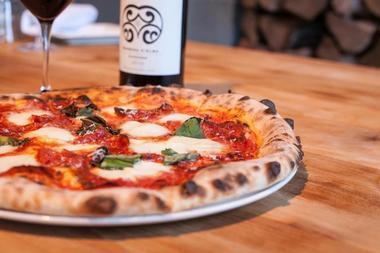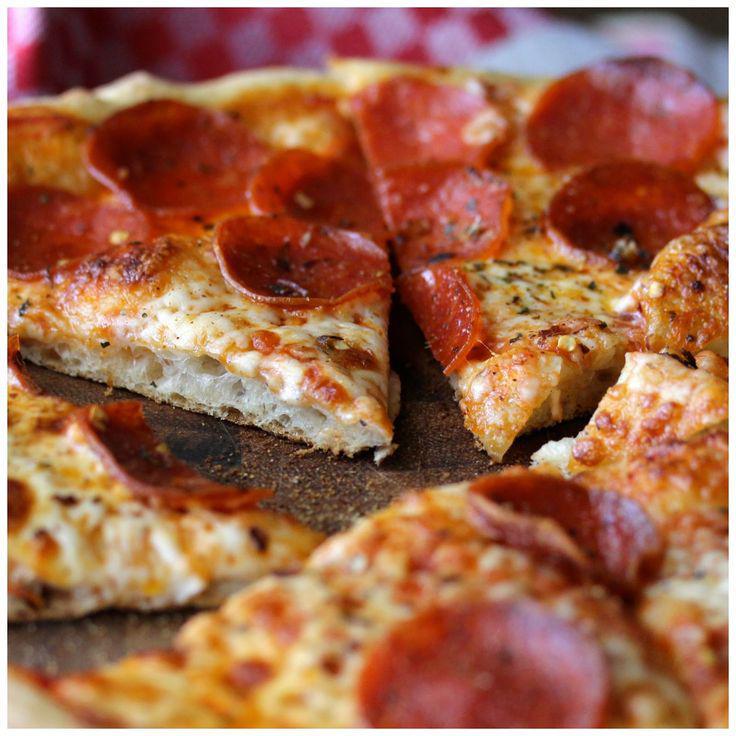The first image is the image on the left, the second image is the image on the right. Considering the images on both sides, is "There is at least one [basil] leaf on the pizza on the right." valid? Answer yes or no. No. The first image is the image on the left, the second image is the image on the right. For the images shown, is this caption "One of the pizzas is a cheese and pepperoni pizza." true? Answer yes or no. Yes. 